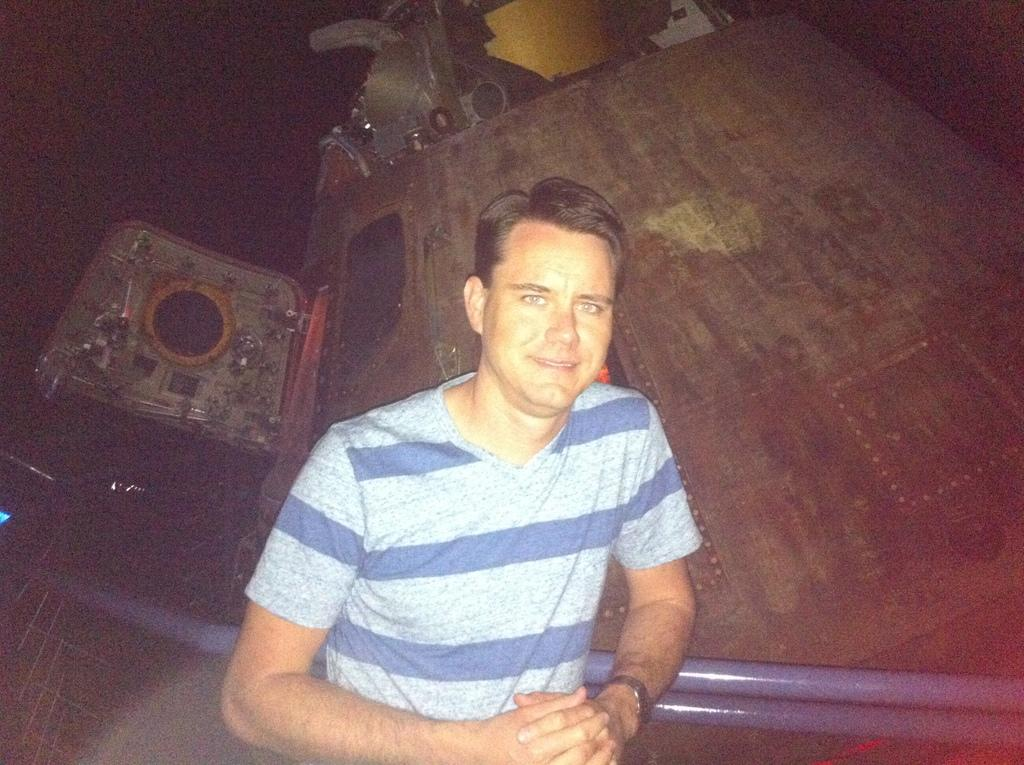What is the main subject of the image? The main subject of the image is a man. What is the man doing in the image? The man is standing in the image. What is the man's facial expression in the image? The man is smiling in the image. What type of clothing is the man wearing in the image? The man is wearing a t-shirt in the image. What accessory is the man wearing in the image? The man is wearing a watch in the image. What can be seen in the background of the image? There are objects in the background of the image. How many chickens are sitting on the sofa in the image? There are no chickens or sofa present in the image. What type of development is taking place in the image? There is no development or construction activity depicted in the image. 